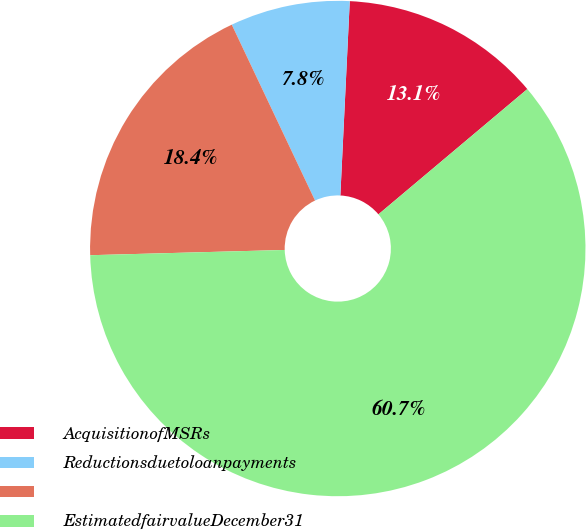Convert chart. <chart><loc_0><loc_0><loc_500><loc_500><pie_chart><fcel>AcquisitionofMSRs<fcel>Reductionsduetoloanpayments<fcel>Unnamed: 2<fcel>EstimatedfairvalueDecember31<nl><fcel>13.1%<fcel>7.81%<fcel>18.39%<fcel>60.7%<nl></chart> 